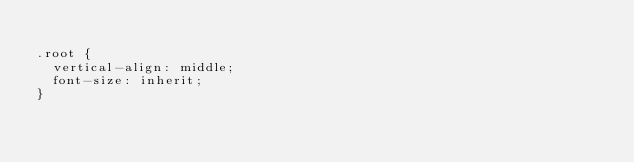Convert code to text. <code><loc_0><loc_0><loc_500><loc_500><_CSS_>
.root {
  vertical-align: middle;
  font-size: inherit;
}
</code> 